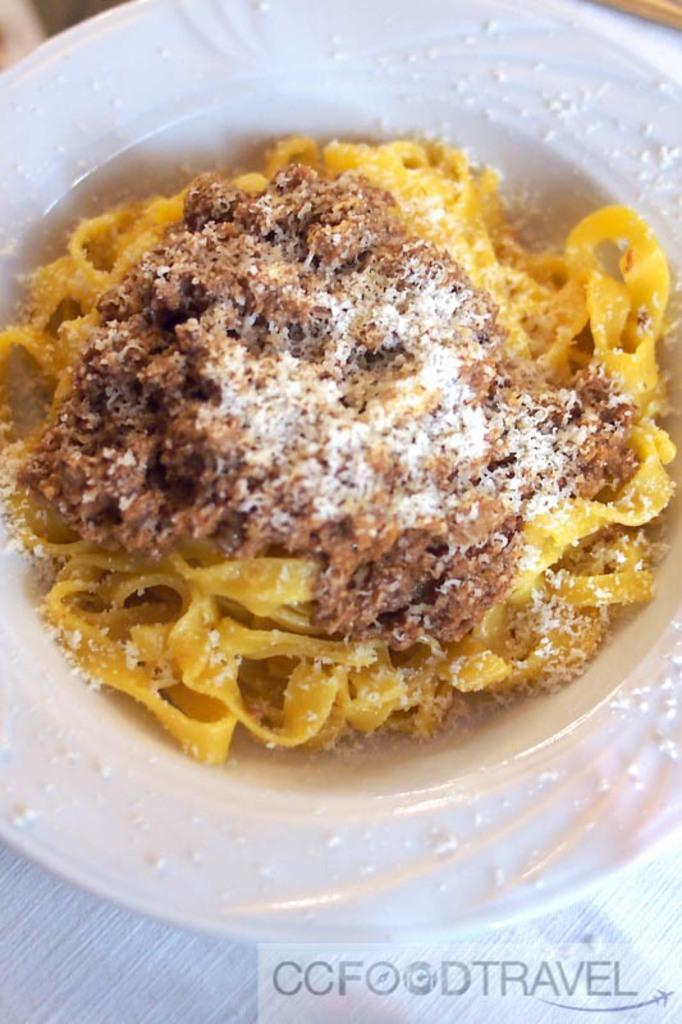What is on the plate that is visible in the image? There is food on a plate in the image. Where is the plate located in the image? The plate is placed on a table. What can be seen at the bottom of the image? There is some text at the bottom of the image. Is there a sink visible in the image? No, there is no sink present in the image. What type of toy can be seen playing with the food on the plate? There is no toy present in the image; it only features a plate of food and some text. 